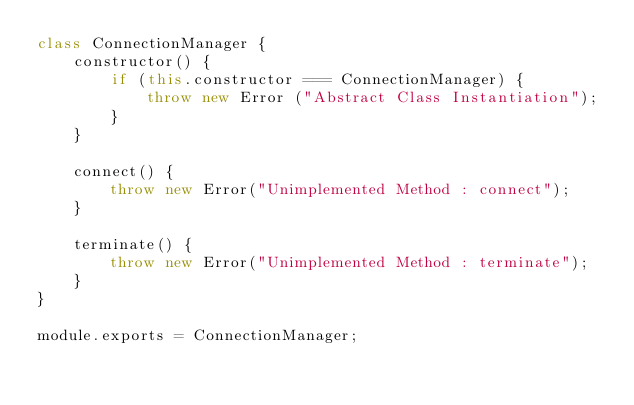<code> <loc_0><loc_0><loc_500><loc_500><_JavaScript_>class ConnectionManager {
    constructor() {
        if (this.constructor === ConnectionManager) {
            throw new Error ("Abstract Class Instantiation");
        }
    }

    connect() {
        throw new Error("Unimplemented Method : connect");
    }

    terminate() {
        throw new Error("Unimplemented Method : terminate");
    }
}

module.exports = ConnectionManager;</code> 